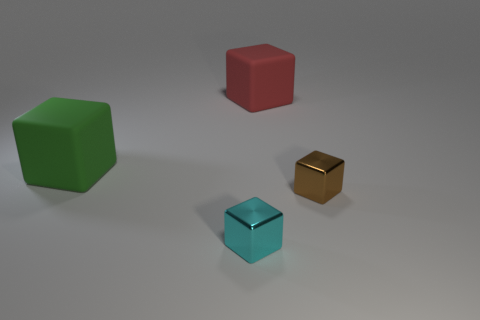How many total objects are there in the image? There are four objects in the image. 